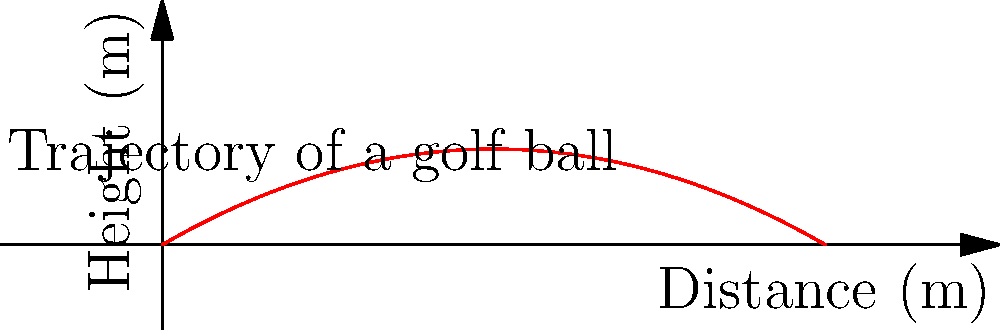A golf ball is hit with an initial velocity of 50 m/s at a launch angle of 30 degrees. Using the trajectory equation, determine the maximum height reached by the golf ball. The graph shows the trajectory of the golf ball. Assume air resistance is negligible. To find the maximum height of the golf ball, we can follow these steps:

1) The trajectory of a projectile (neglecting air resistance) is given by:

   $$y = x \tan(\theta) - \frac{gx^2}{2(v_0 \cos(\theta))^2}$$

   where $y$ is the height, $x$ is the horizontal distance, $\theta$ is the launch angle, $v_0$ is the initial velocity, and $g$ is the acceleration due to gravity.

2) The maximum height occurs at the vertex of the parabola, which is when the vertical velocity component becomes zero. The time to reach this point is:

   $$t_{max} = \frac{v_0 \sin(\theta)}{g}$$

3) Substituting the given values:
   $v_0 = 50$ m/s
   $\theta = 30°$ (convert to radians: $\frac{\pi}{6}$)
   $g = 9.8$ m/s²

   $$t_{max} = \frac{50 \sin(\frac{\pi}{6})}{9.8} = 2.55 \text{ s}$$

4) To find the maximum height, we can use the equation:

   $$y_{max} = v_0 \sin(\theta) t_{max} - \frac{1}{2}gt_{max}^2$$

5) Substituting the values:

   $$y_{max} = 50 \sin(\frac{\pi}{6}) (2.55) - \frac{1}{2}(9.8)(2.55)^2$$

6) Calculating:

   $$y_{max} = 63.75 - 31.88 = 31.87 \text{ m}$$

Therefore, the maximum height reached by the golf ball is approximately 31.87 meters.
Answer: 31.87 m 